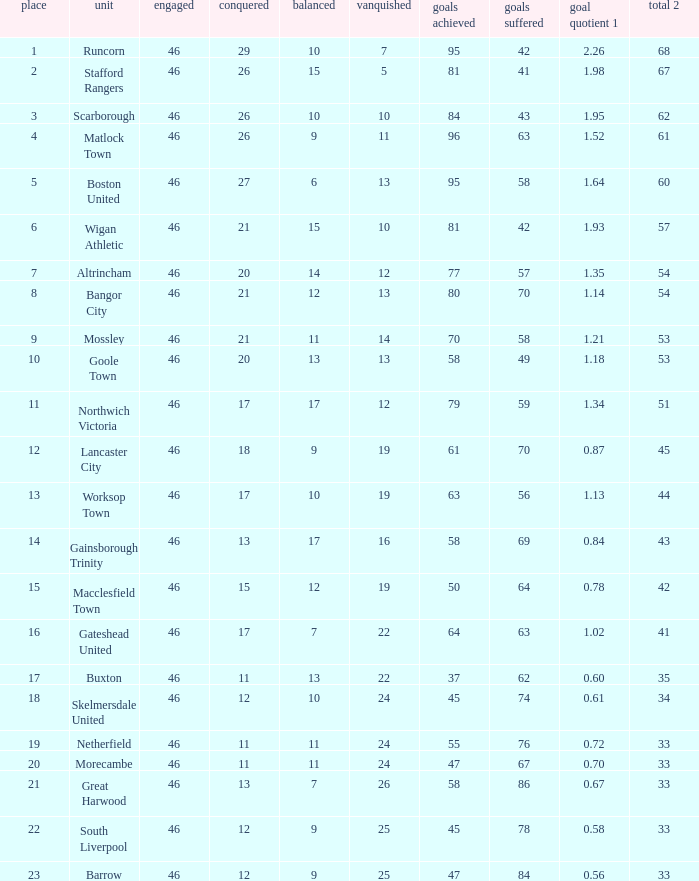Which team had goal averages of 1.34? Northwich Victoria. 